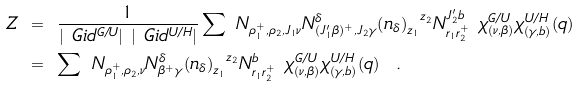<formula> <loc_0><loc_0><loc_500><loc_500>Z & \ = \ \frac { 1 } { | \ G i d ^ { G / U } | \ | \ G i d ^ { U / H } | } \sum \ N _ { \rho _ { 1 } ^ { + } , \rho _ { 2 } , J _ { 1 } \nu } N _ { ( J _ { 1 } ^ { \prime } \beta ) ^ { + } , J _ { 2 } \gamma } ^ { \delta } { \left ( n _ { \delta } \right ) _ { z _ { 1 } } } ^ { z _ { 2 } } N _ { r _ { 1 } r _ { 2 } ^ { + } } ^ { J _ { 2 } ^ { \prime } b } \ \chi _ { ( \nu , \beta ) } ^ { G / U } \chi _ { ( \gamma , b ) } ^ { U / H } ( q ) \\ & \ = \ \sum \ N _ { \rho _ { 1 } ^ { + } , \rho _ { 2 } , \nu } N _ { \beta ^ { + } \gamma } ^ { \delta } { \left ( n _ { \delta } \right ) _ { z _ { 1 } } } ^ { z _ { 2 } } N _ { r _ { 1 } r _ { 2 } ^ { + } } ^ { b } \ \chi _ { ( \nu , \beta ) } ^ { G / U } \chi _ { ( \gamma , b ) } ^ { U / H } ( q ) \ \ .</formula> 